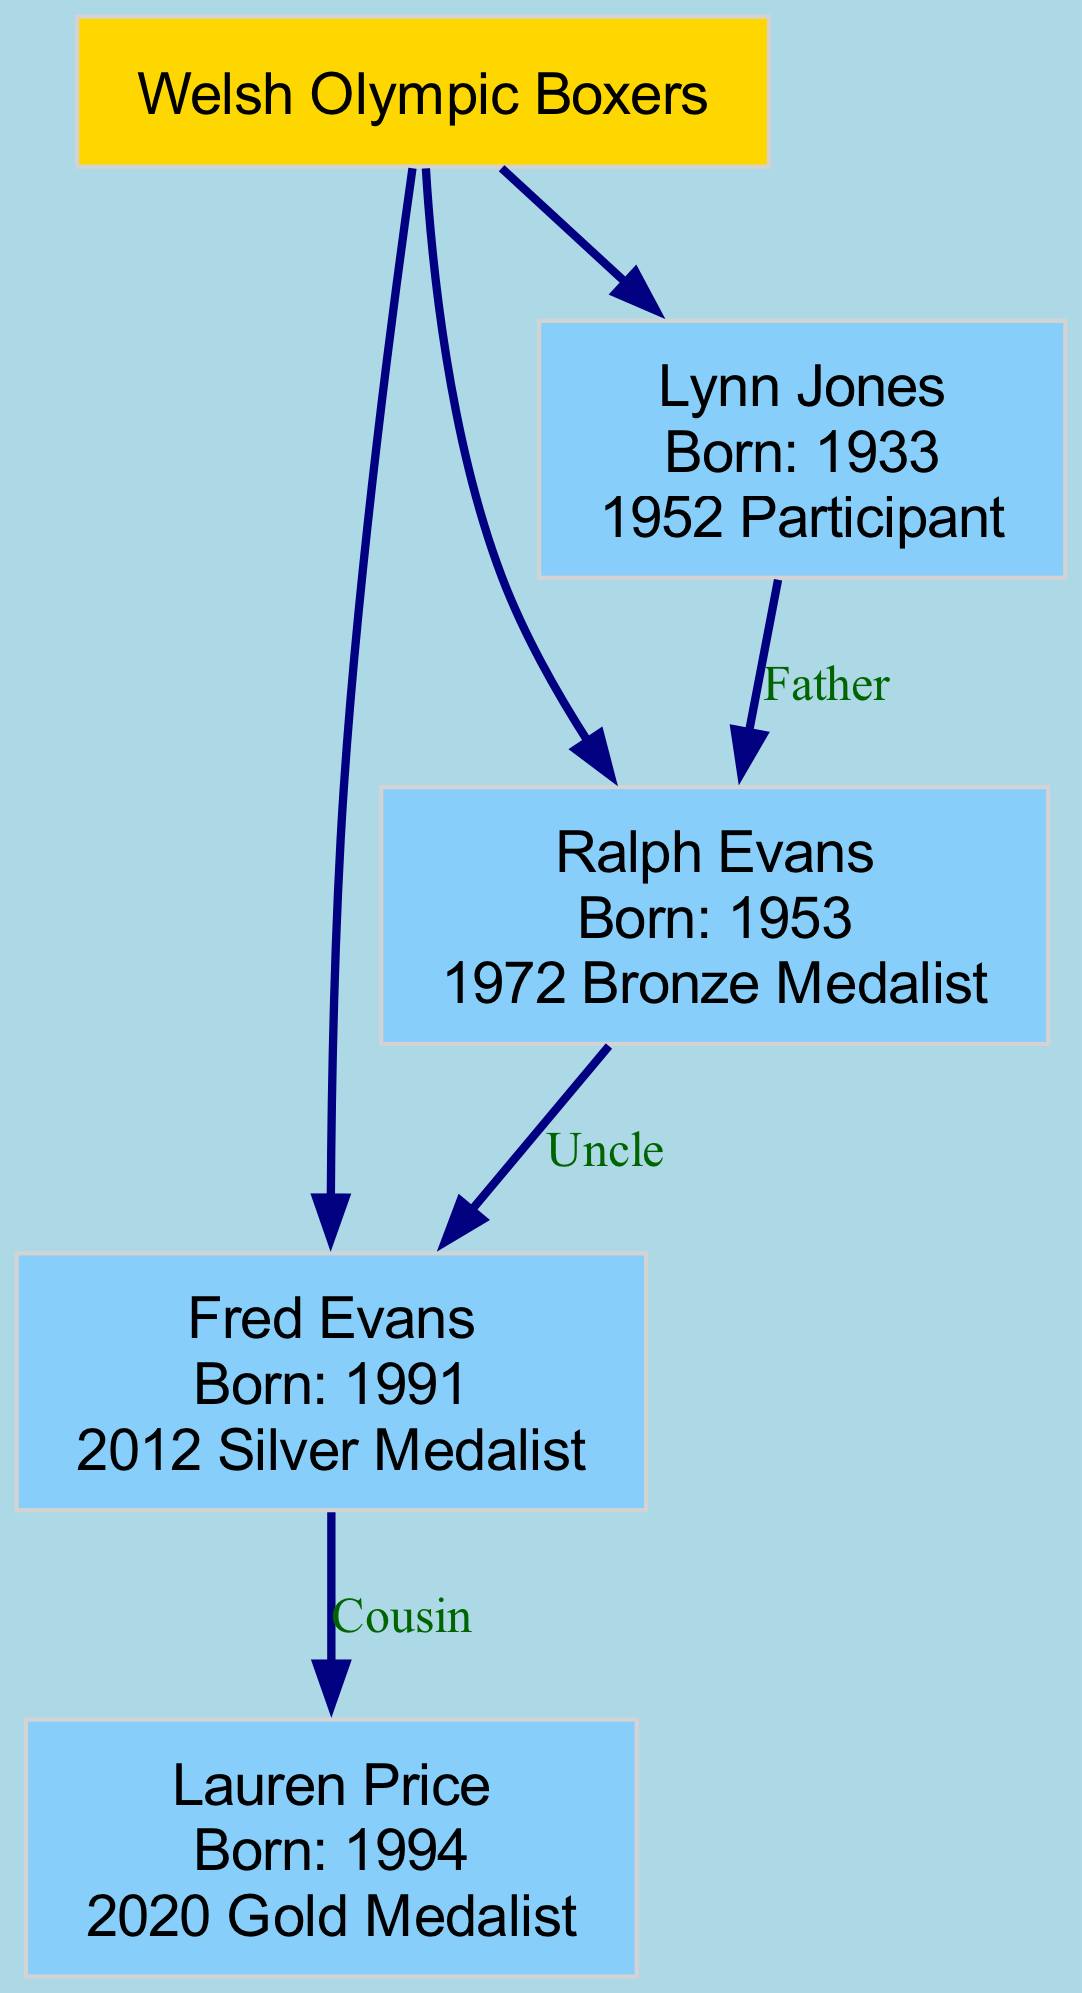What is the Olympic achievement of Fred Evans? Referring to the diagram, Fred Evans is noted as the 2012 Silver Medalist. This is provided in the label for the Fred Evans node in the diagram.
Answer: 2012 Silver Medalist How many Olympic boxers are listed in the family tree? Counting the nodes under the root "Welsh Olympic Boxers," there are four individuals represented: Fred Evans, Ralph Evans, Lynn Jones, and Lauren Price.
Answer: Four Who is Ralph Evans' father? By tracing upward from the Ralph Evans node, the diagram indicates that his father is Lynn Jones, as this relationship is labeled in the connections.
Answer: Lynn Jones How is Lauren Price related to Fred Evans? The diagram labels Lauren Price as a cousin of Fred Evans, clearly shown in the relationship annotations in the family tree.
Answer: Cousin In what year was Ralph Evans born? Inspecting the node for Ralph Evans in the diagram states that he was born in 1953, which provides the necessary information to answer the question.
Answer: 1953 Which Olympic boxer is also the uncle of Fred Evans? According to the diagram, Ralph Evans is indicated as the uncle of Fred Evans through the family relationships displayed in the structure.
Answer: Ralph Evans What is the relationship between Lynn Jones and Ralph Evans? The diagram illustrates that Lynn Jones is the father of Ralph Evans, shown explicitly in the family diagram connections and labels.
Answer: Father How many children does Ralph Evans have? Analyzing the Ralph Evans node, it shows that he has one child listed, who is Fred Evans, according to the family structure in the diagram.
Answer: One What Olympic medal did Lauren Price win? Based on the diagram, Lauren Price is identified as the 2020 Gold Medalist, which is part of her node information.
Answer: 2020 Gold Medalist 